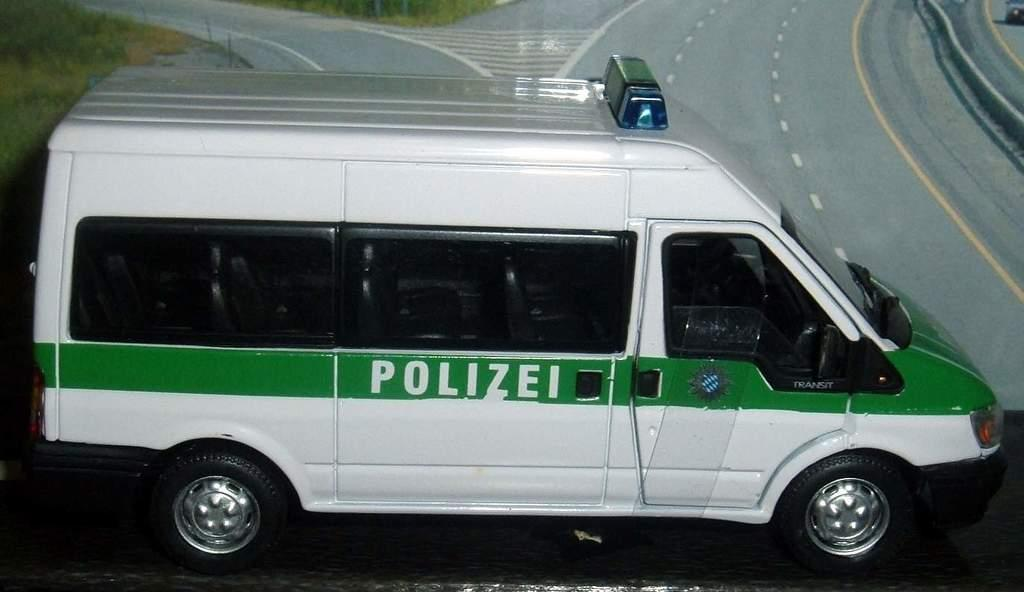<image>
Provide a brief description of the given image. A white and green van that says polizei on the middle section of it. 